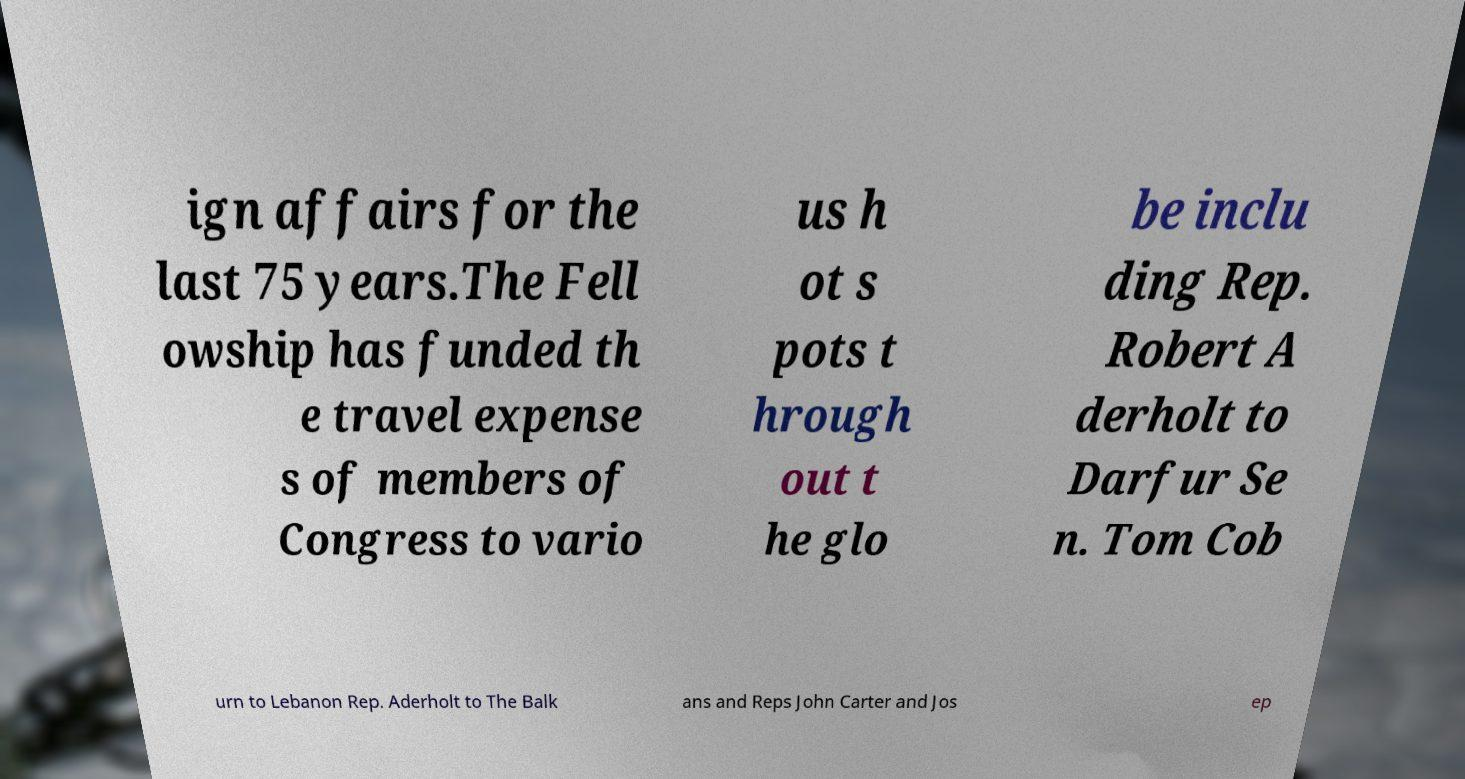I need the written content from this picture converted into text. Can you do that? ign affairs for the last 75 years.The Fell owship has funded th e travel expense s of members of Congress to vario us h ot s pots t hrough out t he glo be inclu ding Rep. Robert A derholt to Darfur Se n. Tom Cob urn to Lebanon Rep. Aderholt to The Balk ans and Reps John Carter and Jos ep 